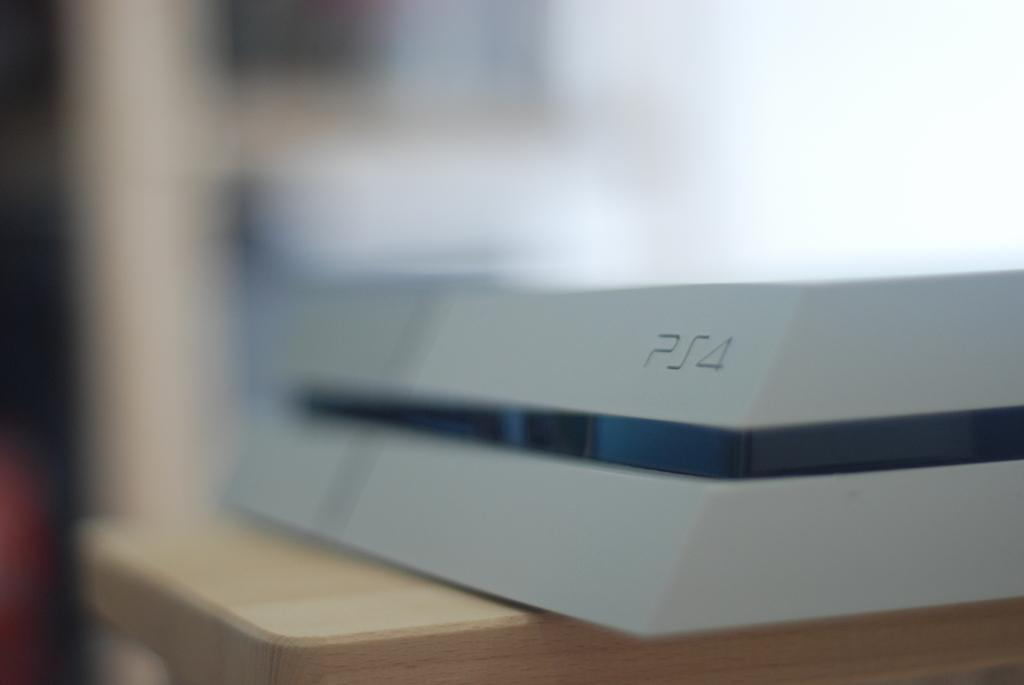<image>
Describe the image concisely. A white and blue PS4 sitting on a small table. 